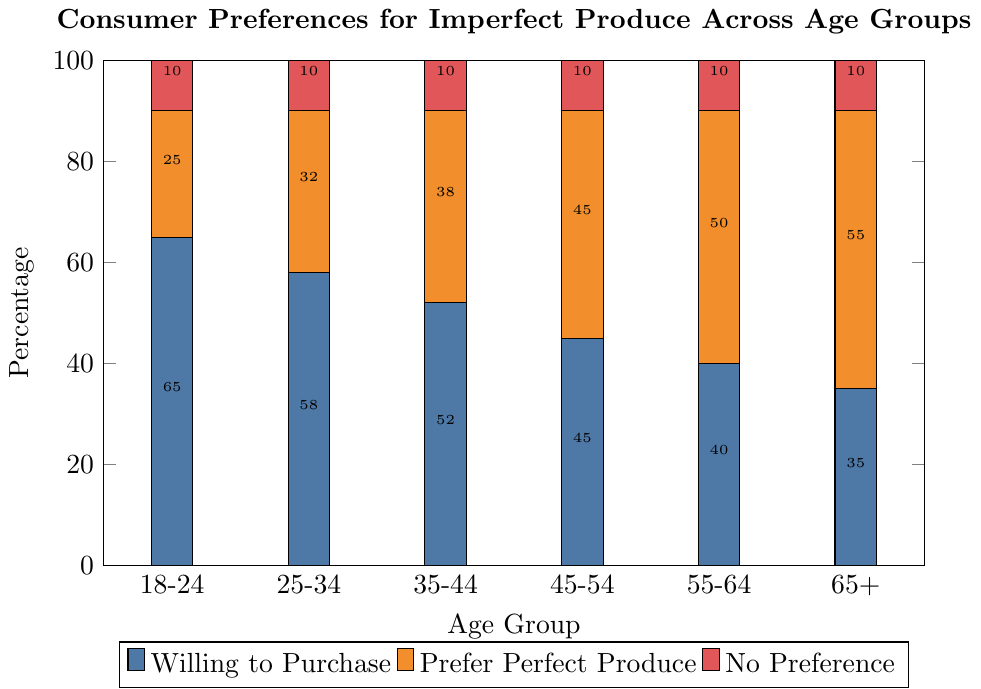what's the age group with the highest percentage willing to purchase imperfect produce? The age group with the highest percentage willing to purchase imperfect produce is indicated by the tallest blue bar in the percentage willing to purchase category. The blue bar for the 18-24 age group is the highest, at 65%.
Answer: 18-24 What is the difference in percentage willing to purchase between the 18-24 and 65+ age groups? The percentage willing to purchase for the 18-24 age group is 65%, and for the 65+ age group, it is 35%. The difference is calculated as 65% - 35%.
Answer: 30% Which age group has an equal percentage of people preferring imperfect produce and perfect produce? The age group with equal percentages for willing to purchase and preferring perfect produce is indicated when the blue bar and orange bar are of equal height. For the 45-54 age group, both categories are at 45%.
Answer: 45-54 What is the trend in the percentage preferring perfect produce as the age increases? Observing the heights of the orange bars for each age group, we can see that the percentage preferring perfect produce increases consistently from the 18-24 age group to the 65+ age group.
Answer: Increases How many age groups have 10% with no preference? The red bar represents the percentage with no preference. All age groups have red bars of equal height, representing 10%.
Answer: 6 What is the average percentage of people willing to purchase imperfect produce across all age groups? The percentages for each age group are 65%, 58%, 52%, 45%, 40%, and 35%. Calculating the average involves summing these percentages and dividing by the number of age groups. (65 + 58 + 52 + 45 + 40 + 35)/6.
Answer: 49.167% Which two age groups have the closest percentages in the category "prefer perfect produce"? Looking at the heights of the orange bars, the age groups 45-54 and 55-64 have percentages of 45% and 50%, respectively, which are the closest among all groups.
Answer: 45-54 and 55-64 What is the sum of percentages of people preferring perfect produce and willing to purchase in the 25-34 age group? In the 25-34 age group, the percentage preferring perfect produce is 32%, and the percentage willing to purchase is 58%. Adding these values gives the sum.
Answer: 90% In which age group is the disparity between people preferring perfect produce and willing to purchase the greatest? To find the greatest disparity, calculate the absolute differences between the percentages for each age group. The age group with the largest difference is 18-24 with a disparity of 40% (65% - 25%).
Answer: 18-24 